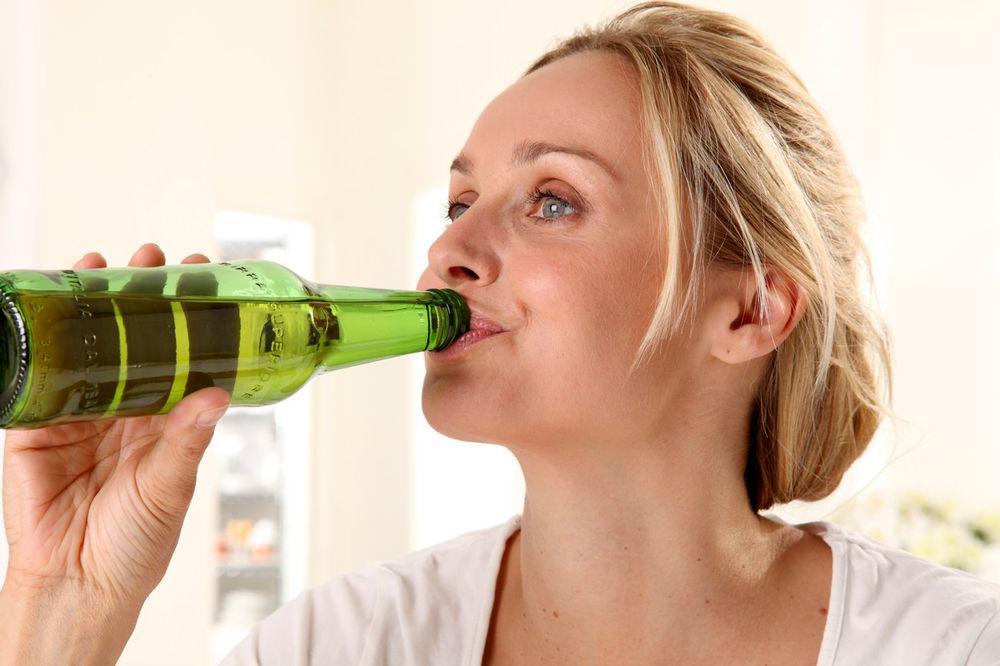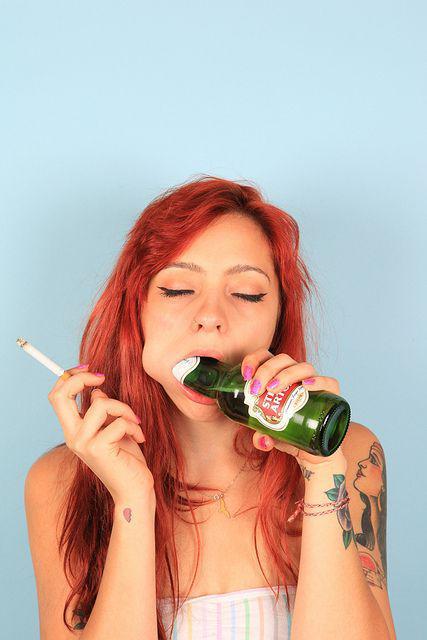The first image is the image on the left, the second image is the image on the right. Analyze the images presented: Is the assertion "The woman in the image on the right is lifting a green bottle to her mouth." valid? Answer yes or no. Yes. The first image is the image on the left, the second image is the image on the right. Examine the images to the left and right. Is the description "The top of a bottle is inside a woman's mouth." accurate? Answer yes or no. Yes. 